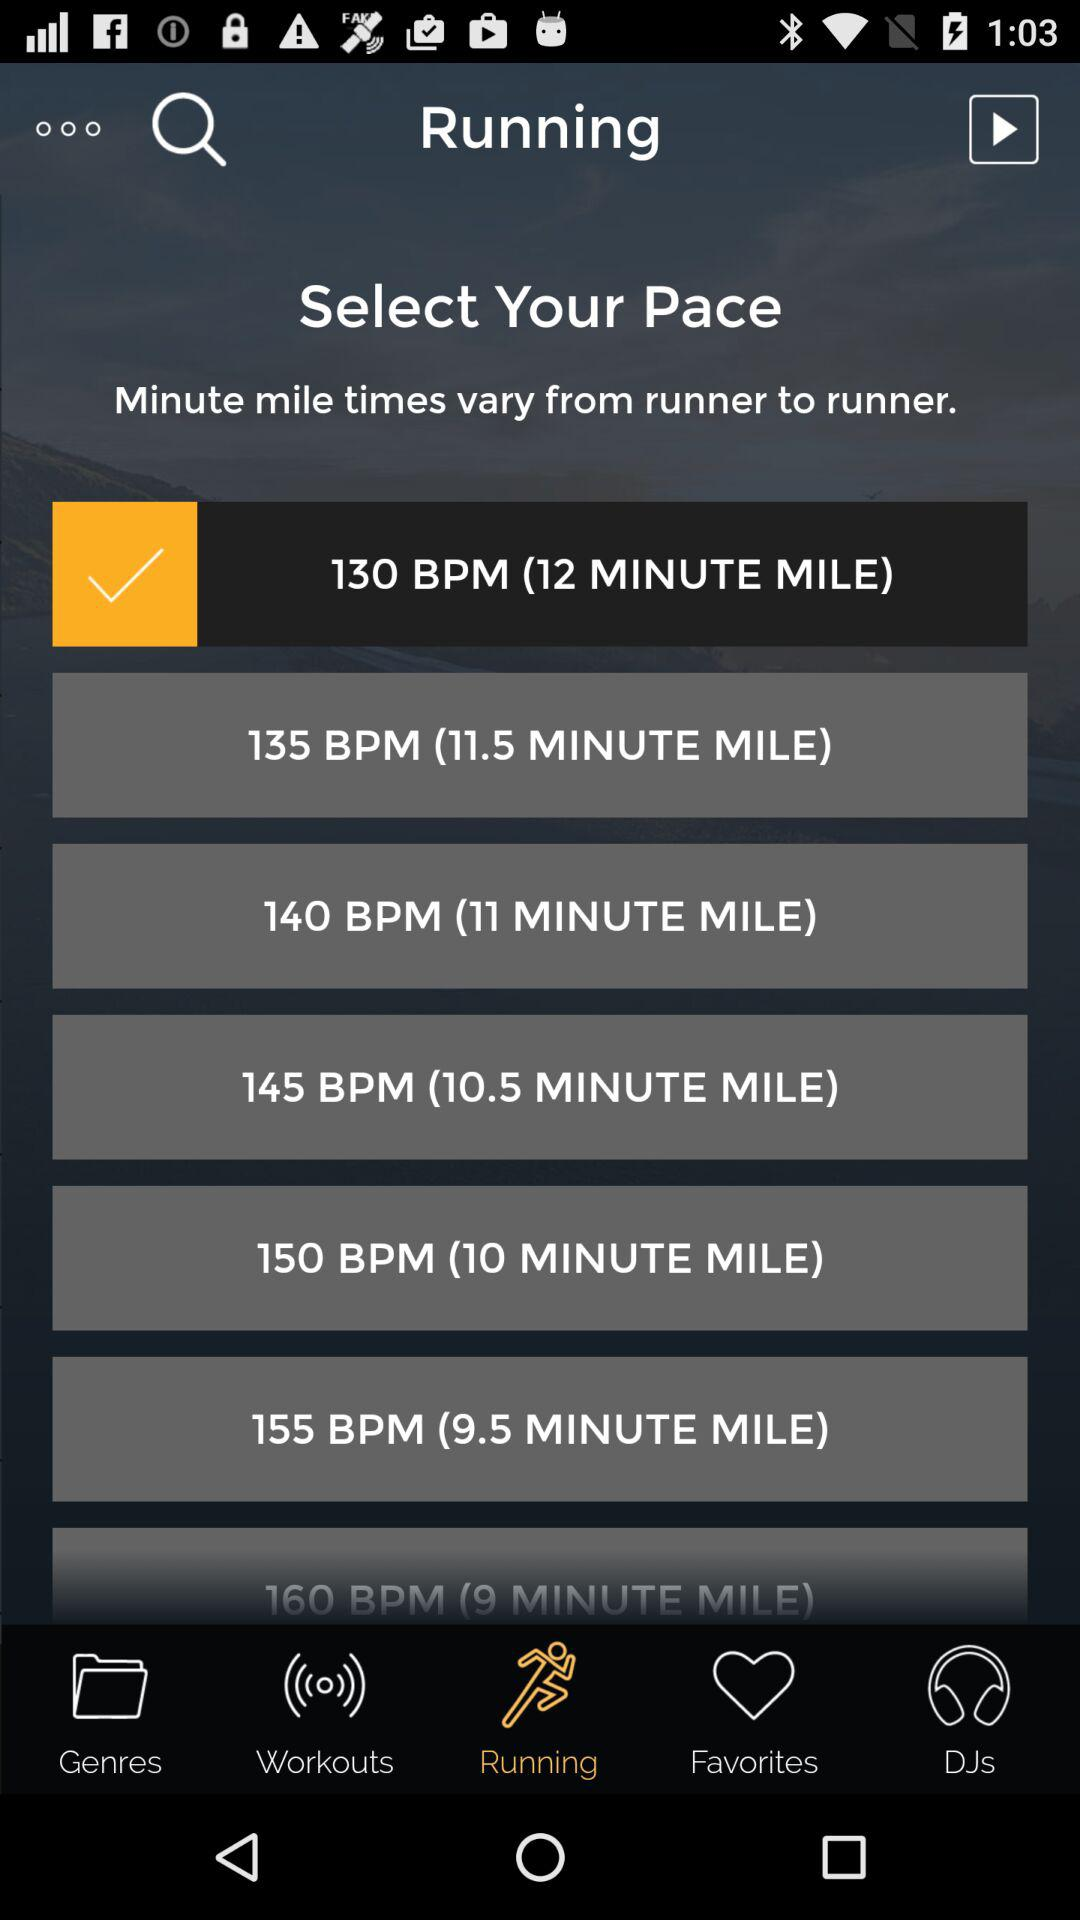Which tab has been selected? The tab that has been selected is "Running". 